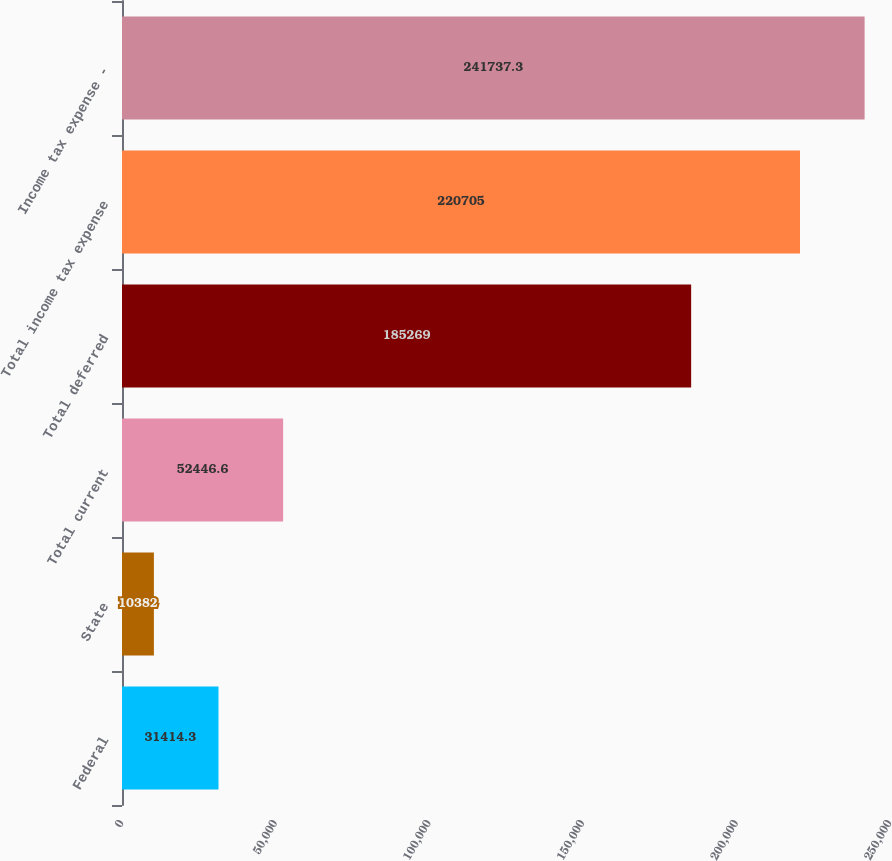Convert chart. <chart><loc_0><loc_0><loc_500><loc_500><bar_chart><fcel>Federal<fcel>State<fcel>Total current<fcel>Total deferred<fcel>Total income tax expense<fcel>Income tax expense -<nl><fcel>31414.3<fcel>10382<fcel>52446.6<fcel>185269<fcel>220705<fcel>241737<nl></chart> 